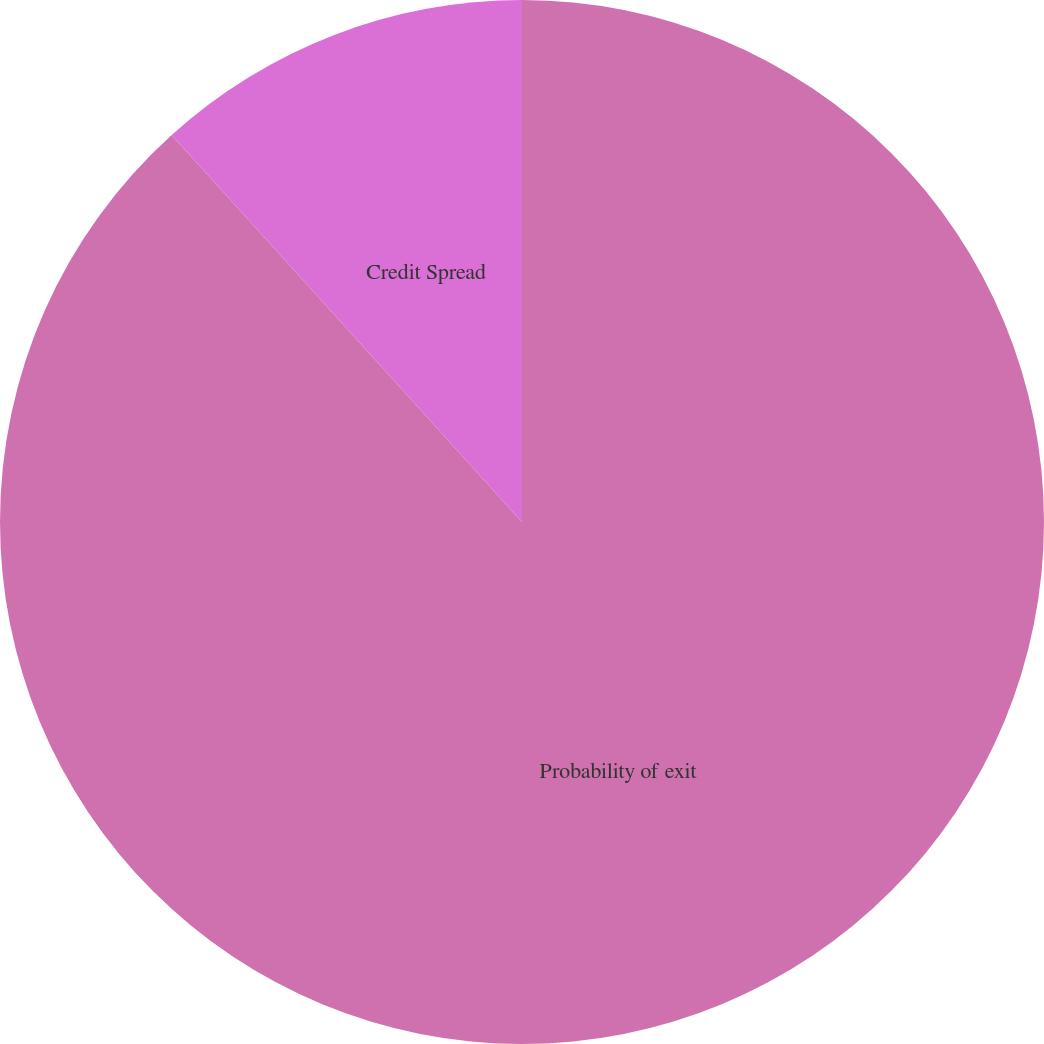Convert chart to OTSL. <chart><loc_0><loc_0><loc_500><loc_500><pie_chart><fcel>Probability of exit<fcel>Credit Spread<nl><fcel>88.29%<fcel>11.71%<nl></chart> 